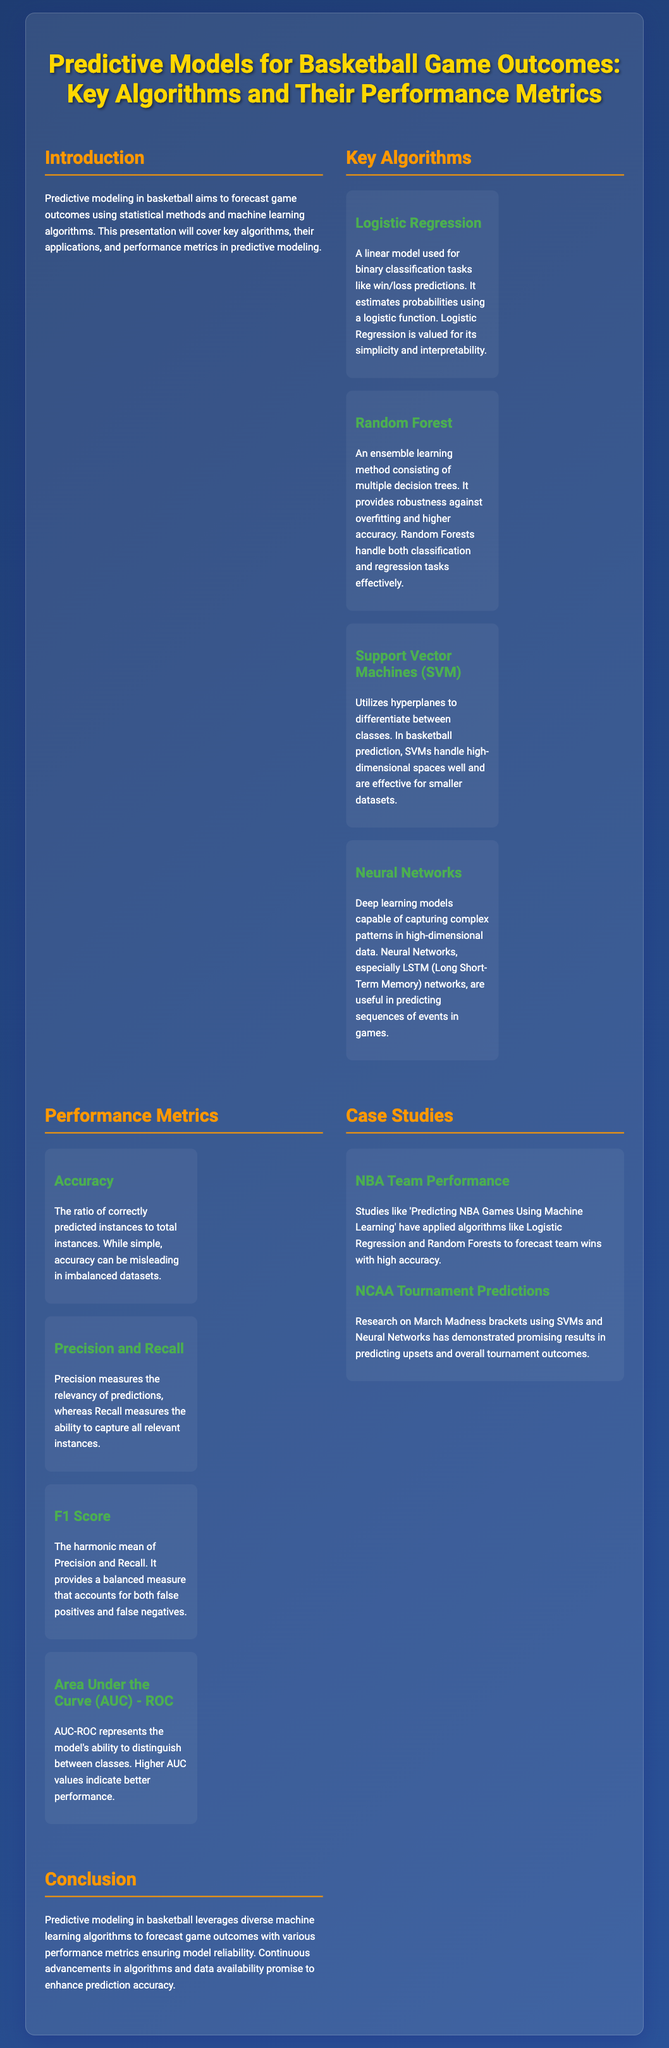What is the focus of predictive modeling in basketball? The focus of predictive modeling in basketball is to forecast game outcomes using statistical methods and machine learning algorithms.
Answer: forecasting game outcomes Which algorithm is used for binary classification tasks? Logistic Regression is described as a linear model used for binary classification tasks.
Answer: Logistic Regression What measures the relevancy of predictions? Precision measures the relevancy of predictions according to the performance metrics section.
Answer: Precision What does AUC-ROC represent in a model? AUC-ROC represents the model's ability to distinguish between classes.
Answer: distinguishing between classes Which case study involves March Madness brackets? The research on predicting NCAA Tournament outcomes involves March Madness brackets.
Answer: NCAA Tournament Predictions What is the harmonic mean of Precision and Recall called? The F1 Score is described as the harmonic mean of Precision and Recall.
Answer: F1 Score How many key algorithms are mentioned in the presentation? Four key algorithms are listed in the document.
Answer: four What type of learning method is Random Forest? Random Forest is described as an ensemble learning method.
Answer: ensemble learning method 